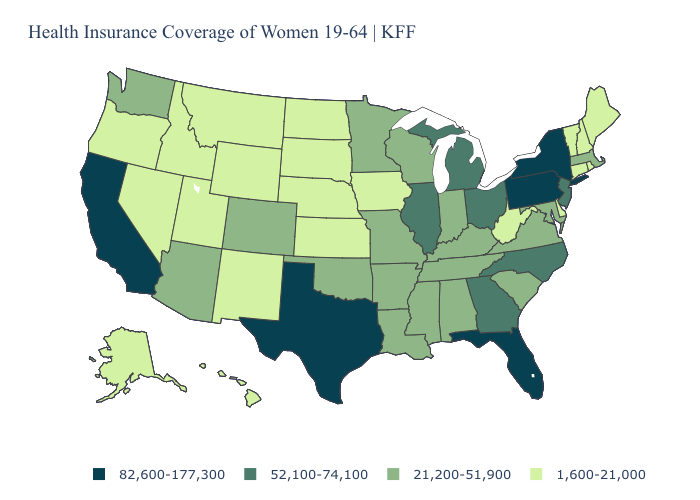Among the states that border Wyoming , does Utah have the highest value?
Short answer required. No. Name the states that have a value in the range 82,600-177,300?
Short answer required. California, Florida, New York, Pennsylvania, Texas. Does the first symbol in the legend represent the smallest category?
Be succinct. No. Which states have the lowest value in the Northeast?
Answer briefly. Connecticut, Maine, New Hampshire, Rhode Island, Vermont. Name the states that have a value in the range 82,600-177,300?
Keep it brief. California, Florida, New York, Pennsylvania, Texas. Does the first symbol in the legend represent the smallest category?
Quick response, please. No. Among the states that border Illinois , does Indiana have the lowest value?
Concise answer only. No. Does the first symbol in the legend represent the smallest category?
Write a very short answer. No. Does New Mexico have a lower value than Tennessee?
Short answer required. Yes. Name the states that have a value in the range 52,100-74,100?
Answer briefly. Georgia, Illinois, Michigan, New Jersey, North Carolina, Ohio. Does the first symbol in the legend represent the smallest category?
Quick response, please. No. Which states hav the highest value in the South?
Write a very short answer. Florida, Texas. Does Massachusetts have the lowest value in the USA?
Write a very short answer. No. Name the states that have a value in the range 82,600-177,300?
Give a very brief answer. California, Florida, New York, Pennsylvania, Texas. Does Kansas have the lowest value in the MidWest?
Quick response, please. Yes. 